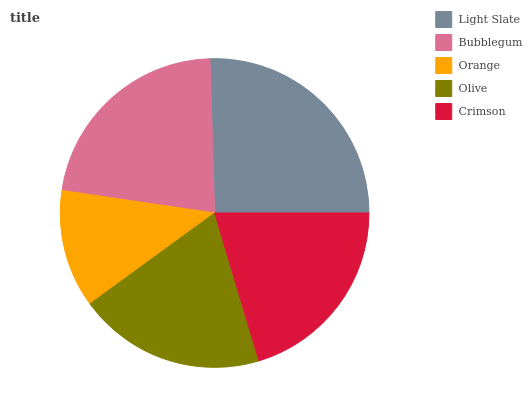Is Orange the minimum?
Answer yes or no. Yes. Is Light Slate the maximum?
Answer yes or no. Yes. Is Bubblegum the minimum?
Answer yes or no. No. Is Bubblegum the maximum?
Answer yes or no. No. Is Light Slate greater than Bubblegum?
Answer yes or no. Yes. Is Bubblegum less than Light Slate?
Answer yes or no. Yes. Is Bubblegum greater than Light Slate?
Answer yes or no. No. Is Light Slate less than Bubblegum?
Answer yes or no. No. Is Crimson the high median?
Answer yes or no. Yes. Is Crimson the low median?
Answer yes or no. Yes. Is Orange the high median?
Answer yes or no. No. Is Light Slate the low median?
Answer yes or no. No. 